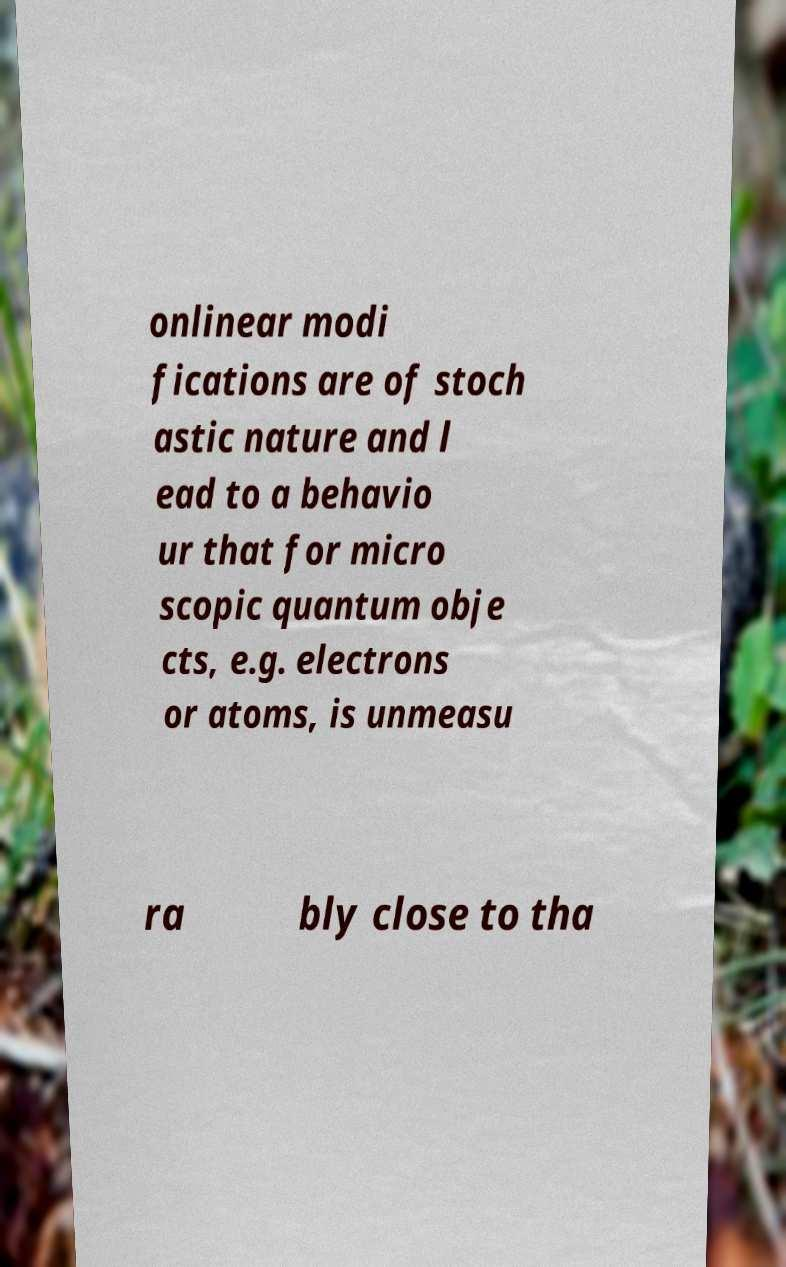For documentation purposes, I need the text within this image transcribed. Could you provide that? onlinear modi fications are of stoch astic nature and l ead to a behavio ur that for micro scopic quantum obje cts, e.g. electrons or atoms, is unmeasu ra bly close to tha 